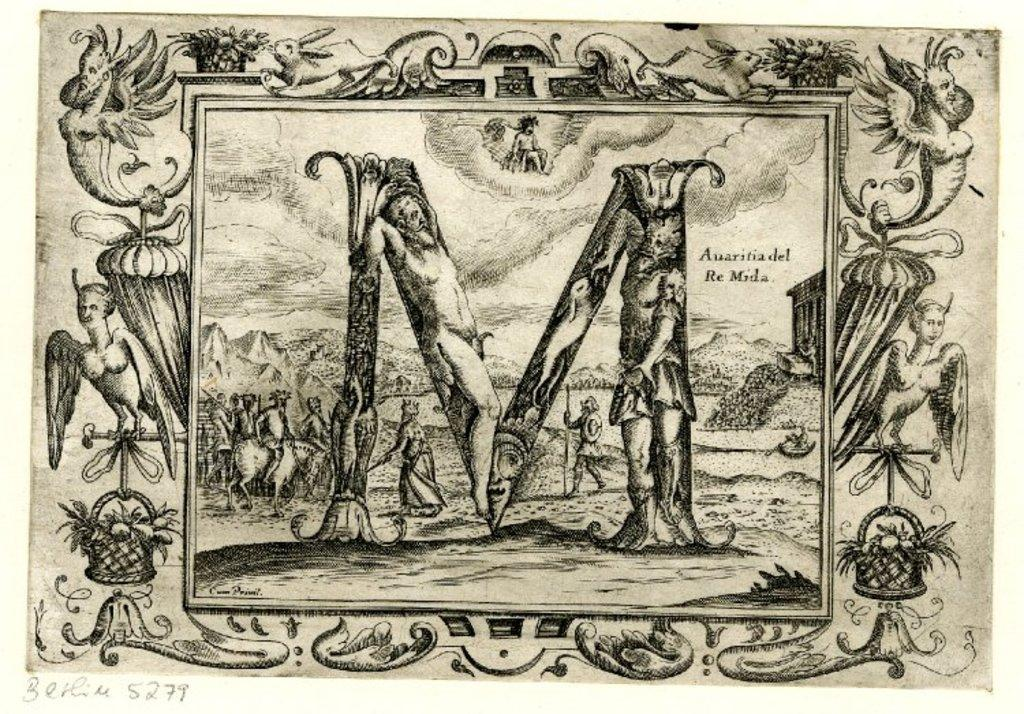What is the color scheme of the image? The image is black and white. What can be seen in the image besides the color scheme? There is a drawing of a letter M in the image. Are there any written elements in the image? Yes, there are written words and numbers at the bottom of the image. How many babies are sitting on the throne in the image? There are no babies or thrones present in the image. What type of twig can be seen growing from the letter M in the image? There is no twig present in the image; it features a drawing of a letter M and written words and numbers. 